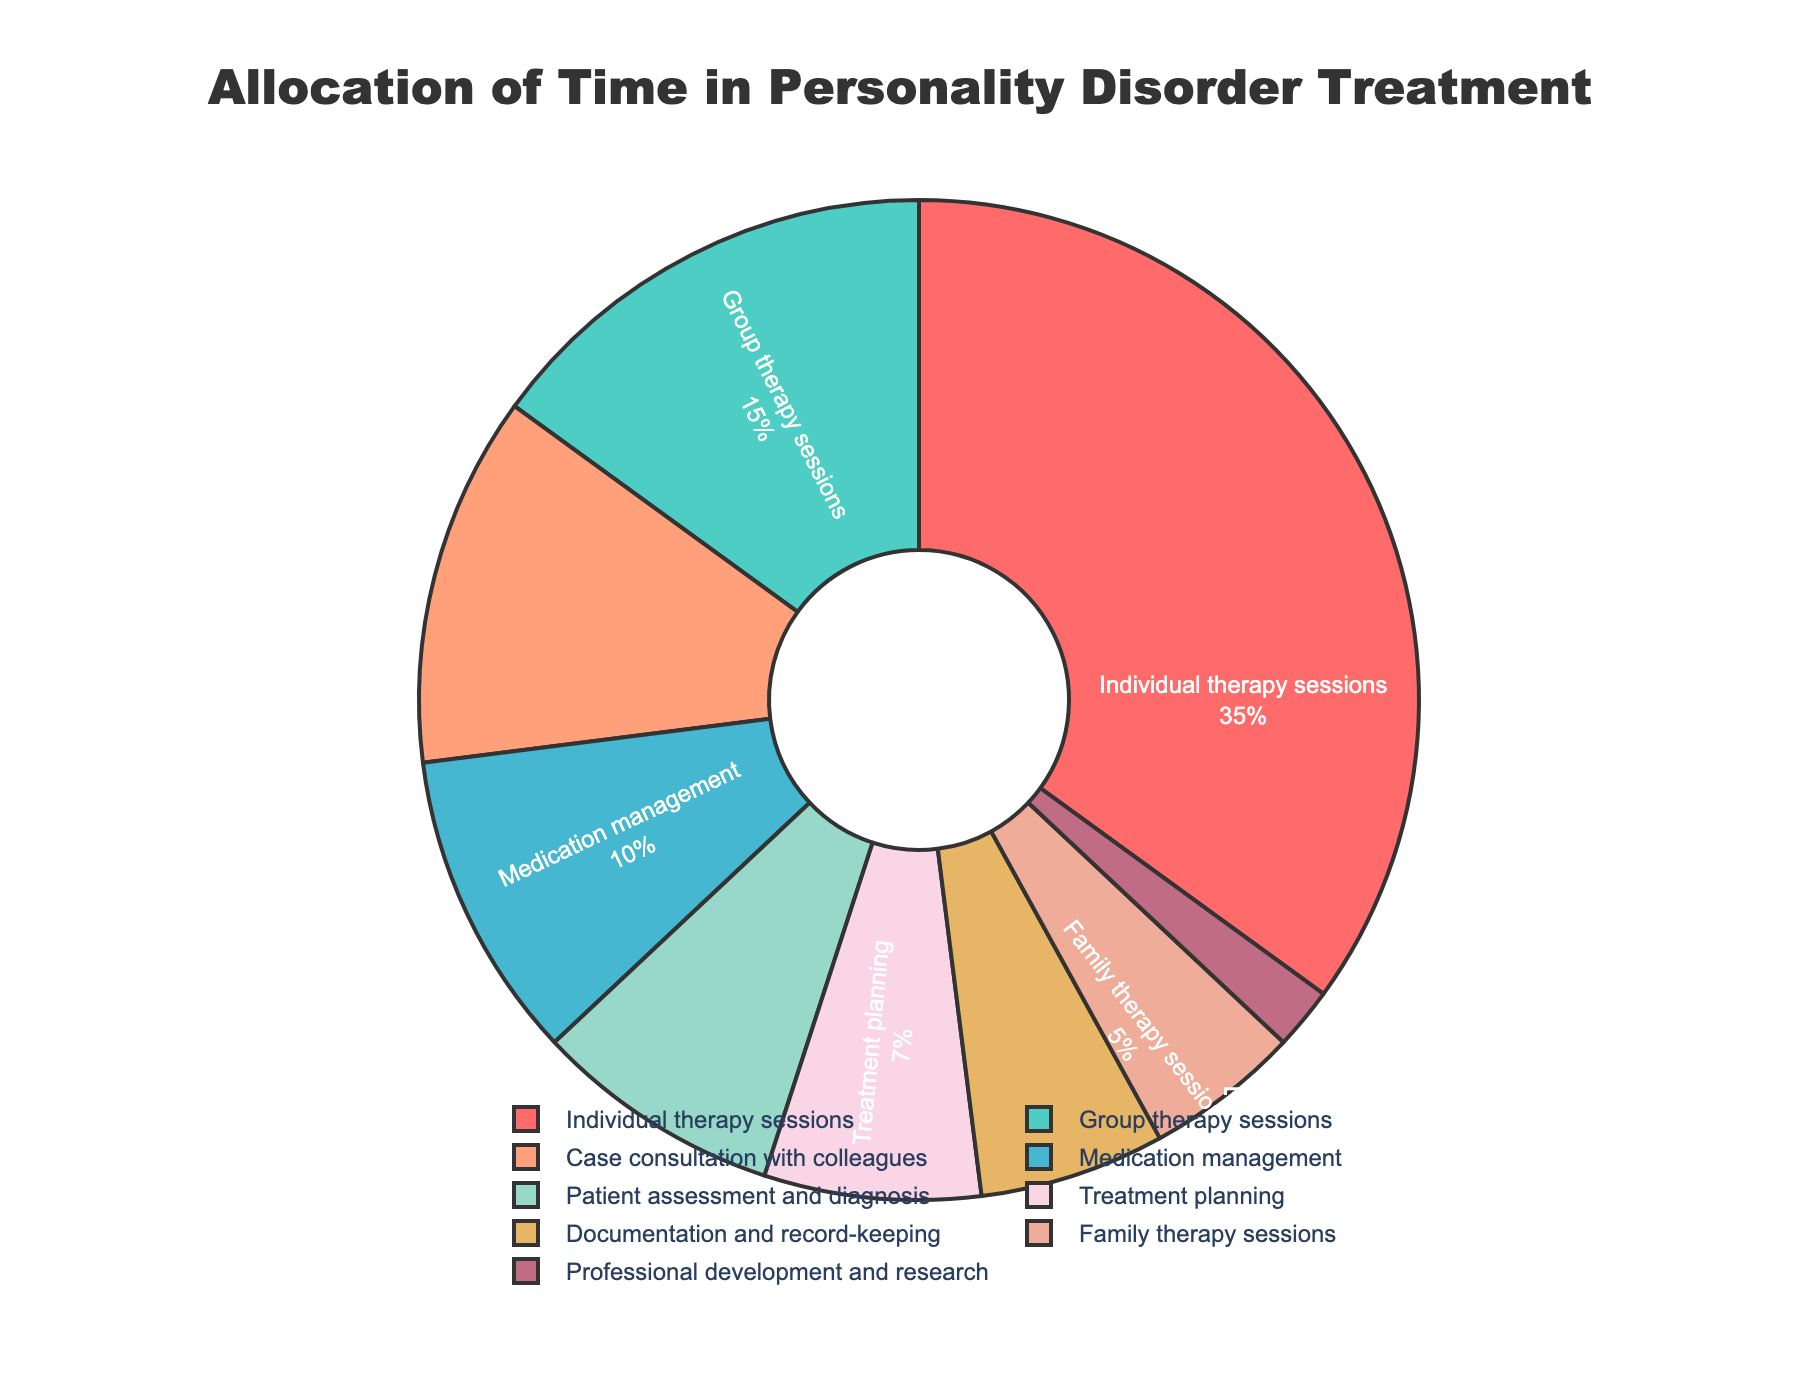What percentage of time is allocated to Group therapy sessions? The slice labeled "Group therapy sessions" shows a percentage indicating how much time is allocated to this activity.
Answer: 15% How much more time is spent on Individual therapy sessions compared to Family therapy sessions? The percentage for Individual therapy sessions is 35%, and for Family therapy sessions, it is 5%. Calculate the difference by subtracting the smaller percentage from the larger one: 35% - 5%.
Answer: 30% Which aspect takes up the least amount of time, and what percentage is it? By examining all the slices in the pie chart, the smallest slice represents "Professional development and research," which has the smallest percentage.
Answer: Professional development and research, 2% Which aspects combined take up exactly 20% of the time? Find two or more slices whose percentages add up to 20%. Here, "Medication management" (10%) and "Documentation and record-keeping" (6%) along with "Professional development and research" (2%) total 18%, so we need to add "Family therapy sessions" (5%) to achieve a more accurate combination.
Answer: Documentation and record-keeping and Professional development and research Is more time spent on Case consultation with colleagues or Patient assessment and diagnosis, and by how much? Compare the percentages of "Case consultation with colleagues" (12%) and "Patient assessment and diagnosis" (8%). Subtract the smaller percentage from the larger one: 12% - 8%.
Answer: Case consultation with colleagues, by 4% What is the sum of the percentages allocated to Treatment planning and Documentation and record-keeping? Add the percentages for "Treatment planning" (7%) and "Documentation and record-keeping" (6%): 7% + 6%.
Answer: 13% Which aspect's time allocation is represented by a slice colored red? Identify the slice colored red in the pie chart, which represents a specific aspect and its corresponding percentage.
Answer: Individual therapy sessions What is the combined percentage of time spent on Individual therapy sessions, Group therapy sessions, and Family therapy sessions? Add the percentages for "Individual therapy sessions" (35%), "Group therapy sessions" (15%), and "Family therapy sessions" (5%): 35% + 15% + 5%.
Answer: 55% Among the activities shown, which one is dedicated less than 10% of the time except for Professional development and research? Identify slices with less than 10% allocation, excluding the one with the lowest percentage and focusing on other segments.
Answer: Patient assessment and diagnosis, 8% How much more time is spent on Treatment planning than on Professional development and research? Compare the two durations: "Treatment planning" (7%) and "Professional development and research" (2%). Subtract the smaller percentage from the larger one: 7% - 2%.
Answer: 5% 